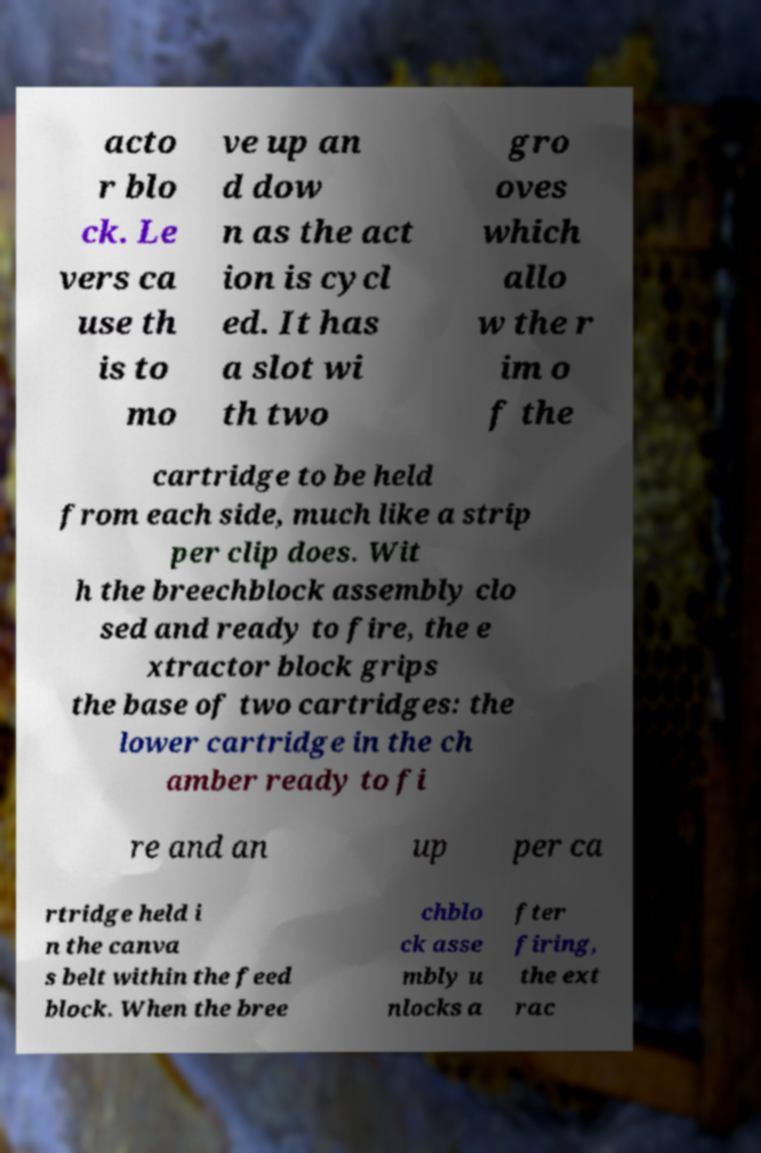Please read and relay the text visible in this image. What does it say? acto r blo ck. Le vers ca use th is to mo ve up an d dow n as the act ion is cycl ed. It has a slot wi th two gro oves which allo w the r im o f the cartridge to be held from each side, much like a strip per clip does. Wit h the breechblock assembly clo sed and ready to fire, the e xtractor block grips the base of two cartridges: the lower cartridge in the ch amber ready to fi re and an up per ca rtridge held i n the canva s belt within the feed block. When the bree chblo ck asse mbly u nlocks a fter firing, the ext rac 